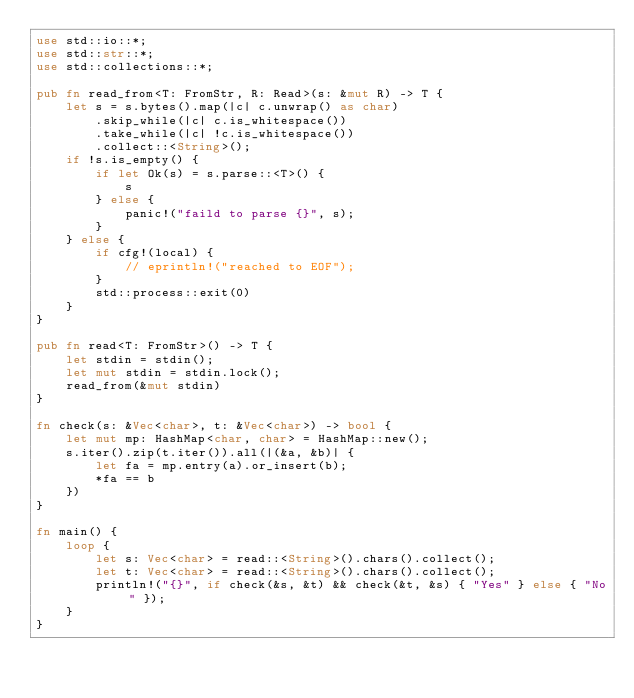Convert code to text. <code><loc_0><loc_0><loc_500><loc_500><_Rust_>use std::io::*;
use std::str::*;
use std::collections::*;

pub fn read_from<T: FromStr, R: Read>(s: &mut R) -> T {
    let s = s.bytes().map(|c| c.unwrap() as char)
        .skip_while(|c| c.is_whitespace())
        .take_while(|c| !c.is_whitespace())
        .collect::<String>();
    if !s.is_empty() {
        if let Ok(s) = s.parse::<T>() {
            s
        } else {
            panic!("faild to parse {}", s);
        }
    } else {
        if cfg!(local) {
            // eprintln!("reached to EOF");
        }
        std::process::exit(0)
    }
}

pub fn read<T: FromStr>() -> T {
    let stdin = stdin();
    let mut stdin = stdin.lock();
    read_from(&mut stdin)
}

fn check(s: &Vec<char>, t: &Vec<char>) -> bool {
    let mut mp: HashMap<char, char> = HashMap::new();
    s.iter().zip(t.iter()).all(|(&a, &b)| {
        let fa = mp.entry(a).or_insert(b);
        *fa == b
    })
}

fn main() {
    loop {
        let s: Vec<char> = read::<String>().chars().collect();
        let t: Vec<char> = read::<String>().chars().collect();
        println!("{}", if check(&s, &t) && check(&t, &s) { "Yes" } else { "No" });
    }
}
</code> 